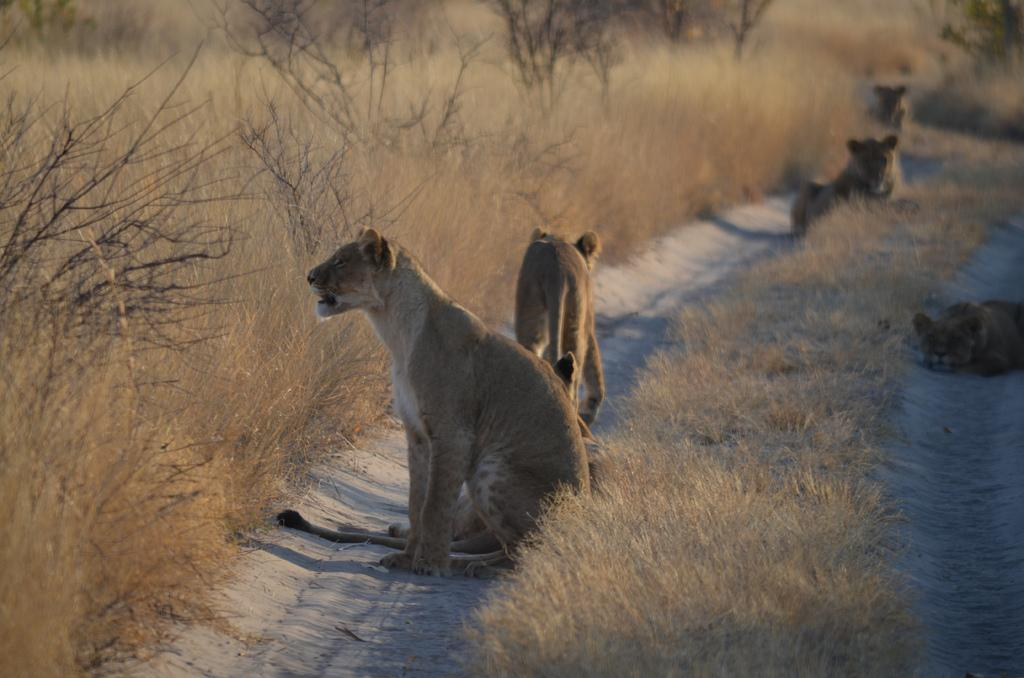What animals are present on the ground in the image? There are lions on the ground in the image. What type of vegetation can be seen in the image? There are trees and grass in the image. What musical instrument is being played by the lions in the image? There is no musical instrument present in the image, and the lions are not playing any instruments. 